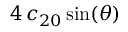<formula> <loc_0><loc_0><loc_500><loc_500>4 \, c _ { 2 0 } \sin ( \theta )</formula> 